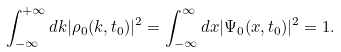Convert formula to latex. <formula><loc_0><loc_0><loc_500><loc_500>\int _ { - \infty } ^ { + \infty } d k | \rho _ { 0 } ( k , t _ { 0 } ) | ^ { 2 } = \int _ { - \infty } ^ { \infty } d x | \Psi _ { 0 } ( x , t _ { 0 } ) | ^ { 2 } = 1 .</formula> 